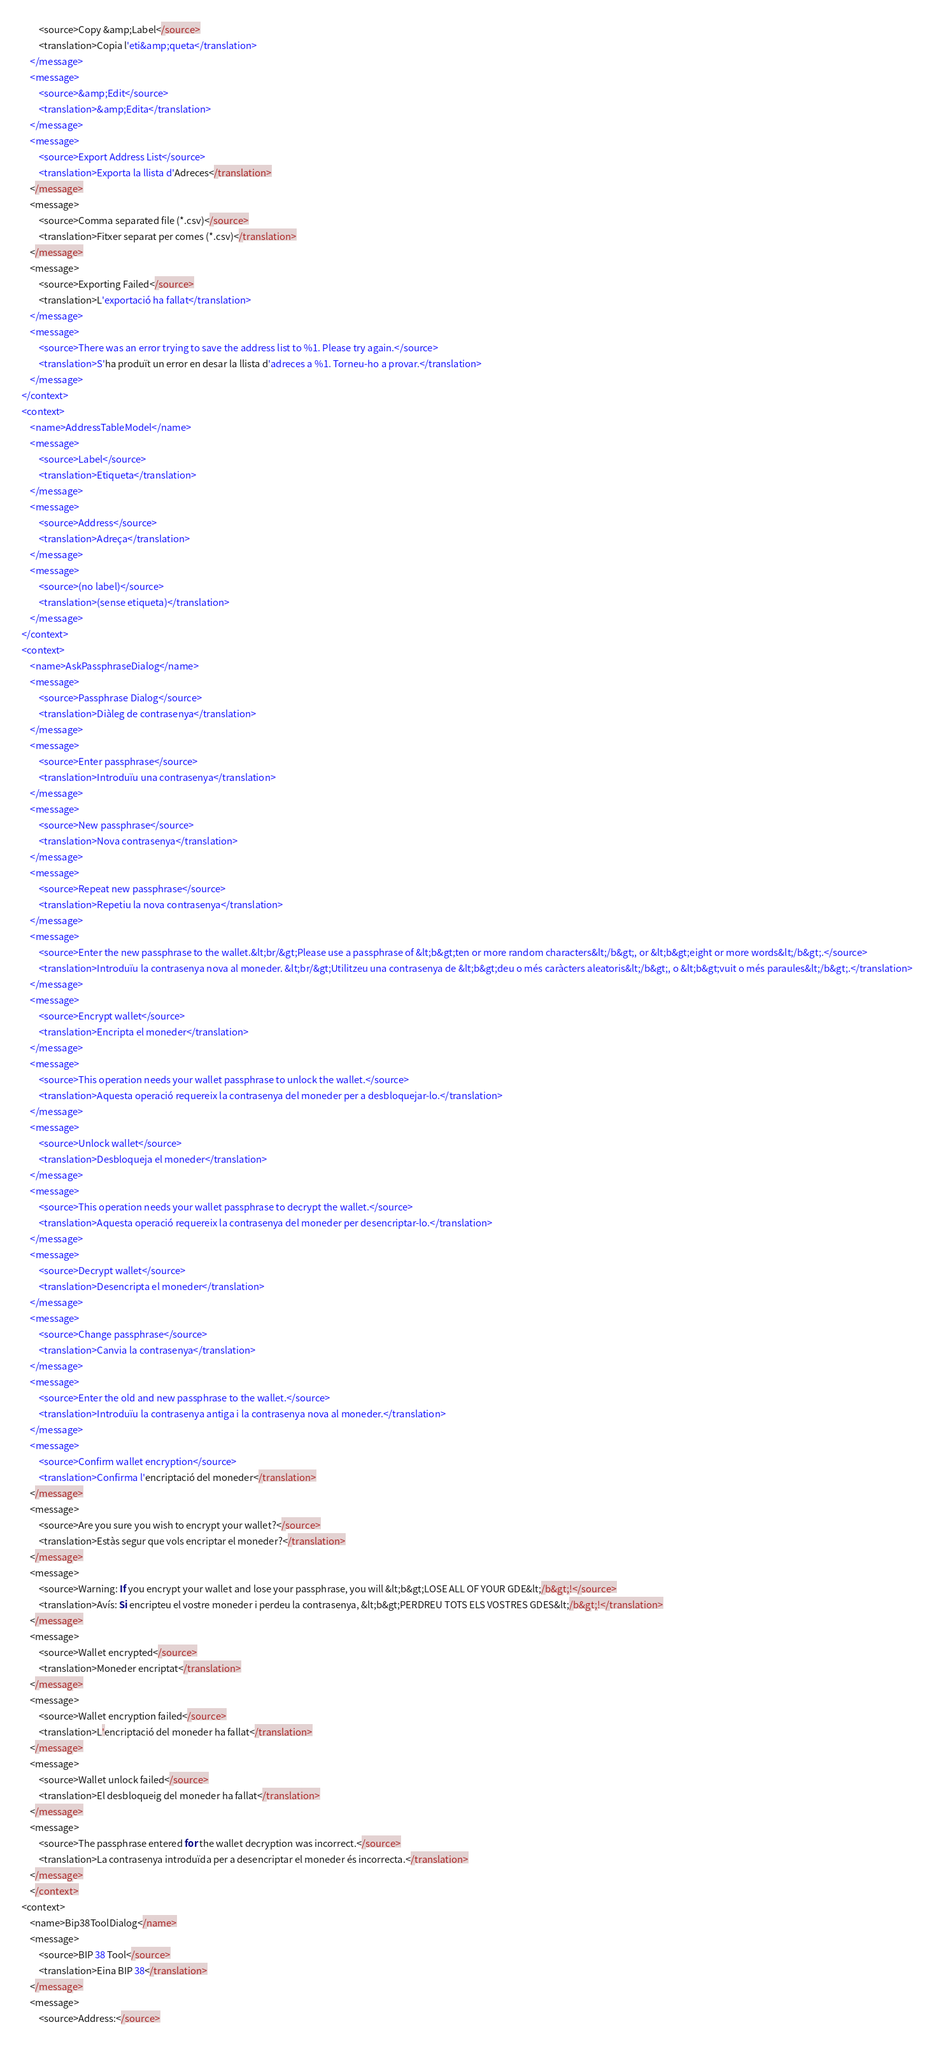<code> <loc_0><loc_0><loc_500><loc_500><_TypeScript_>        <source>Copy &amp;Label</source>
        <translation>Copia l'eti&amp;queta</translation>
    </message>
    <message>
        <source>&amp;Edit</source>
        <translation>&amp;Edita</translation>
    </message>
    <message>
        <source>Export Address List</source>
        <translation>Exporta la llista d'Adreces</translation>
    </message>
    <message>
        <source>Comma separated file (*.csv)</source>
        <translation>Fitxer separat per comes (*.csv)</translation>
    </message>
    <message>
        <source>Exporting Failed</source>
        <translation>L'exportació ha fallat</translation>
    </message>
    <message>
        <source>There was an error trying to save the address list to %1. Please try again.</source>
        <translation>S'ha produït un error en desar la llista d'adreces a %1. Torneu-ho a provar.</translation>
    </message>
</context>
<context>
    <name>AddressTableModel</name>
    <message>
        <source>Label</source>
        <translation>Etiqueta</translation>
    </message>
    <message>
        <source>Address</source>
        <translation>Adreça</translation>
    </message>
    <message>
        <source>(no label)</source>
        <translation>(sense etiqueta)</translation>
    </message>
</context>
<context>
    <name>AskPassphraseDialog</name>
    <message>
        <source>Passphrase Dialog</source>
        <translation>Diàleg de contrasenya</translation>
    </message>
    <message>
        <source>Enter passphrase</source>
        <translation>Introduïu una contrasenya</translation>
    </message>
    <message>
        <source>New passphrase</source>
        <translation>Nova contrasenya</translation>
    </message>
    <message>
        <source>Repeat new passphrase</source>
        <translation>Repetiu la nova contrasenya</translation>
    </message>
    <message>
        <source>Enter the new passphrase to the wallet.&lt;br/&gt;Please use a passphrase of &lt;b&gt;ten or more random characters&lt;/b&gt;, or &lt;b&gt;eight or more words&lt;/b&gt;.</source>
        <translation>Introduïu la contrasenya nova al moneder. &lt;br/&gt;Utilitzeu una contrasenya de &lt;b&gt;deu o més caràcters aleatoris&lt;/b&gt;, o &lt;b&gt;vuit o més paraules&lt;/b&gt;.</translation>
    </message>
    <message>
        <source>Encrypt wallet</source>
        <translation>Encripta el moneder</translation>
    </message>
    <message>
        <source>This operation needs your wallet passphrase to unlock the wallet.</source>
        <translation>Aquesta operació requereix la contrasenya del moneder per a desbloquejar-lo.</translation>
    </message>
    <message>
        <source>Unlock wallet</source>
        <translation>Desbloqueja el moneder</translation>
    </message>
    <message>
        <source>This operation needs your wallet passphrase to decrypt the wallet.</source>
        <translation>Aquesta operació requereix la contrasenya del moneder per desencriptar-lo.</translation>
    </message>
    <message>
        <source>Decrypt wallet</source>
        <translation>Desencripta el moneder</translation>
    </message>
    <message>
        <source>Change passphrase</source>
        <translation>Canvia la contrasenya</translation>
    </message>
    <message>
        <source>Enter the old and new passphrase to the wallet.</source>
        <translation>Introduïu la contrasenya antiga i la contrasenya nova al moneder.</translation>
    </message>
    <message>
        <source>Confirm wallet encryption</source>
        <translation>Confirma l'encriptació del moneder</translation>
    </message>
    <message>
        <source>Are you sure you wish to encrypt your wallet?</source>
        <translation>Estàs segur que vols encriptar el moneder?</translation>
    </message>
    <message>
        <source>Warning: If you encrypt your wallet and lose your passphrase, you will &lt;b&gt;LOSE ALL OF YOUR GDE&lt;/b&gt;!</source>
        <translation>Avís: Si encripteu el vostre moneder i perdeu la contrasenya, &lt;b&gt;PERDREU TOTS ELS VOSTRES GDES&lt;/b&gt;!</translation>
    </message>
    <message>
        <source>Wallet encrypted</source>
        <translation>Moneder encriptat</translation>
    </message>
    <message>
        <source>Wallet encryption failed</source>
        <translation>L'encriptació del moneder ha fallat</translation>
    </message>
    <message>
        <source>Wallet unlock failed</source>
        <translation>El desbloqueig del moneder ha fallat</translation>
    </message>
    <message>
        <source>The passphrase entered for the wallet decryption was incorrect.</source>
        <translation>La contrasenya introduïda per a desencriptar el moneder és incorrecta.</translation>
    </message>
    </context>
<context>
    <name>Bip38ToolDialog</name>
    <message>
        <source>BIP 38 Tool</source>
        <translation>Eina BIP 38</translation>
    </message>
    <message>
        <source>Address:</source></code> 